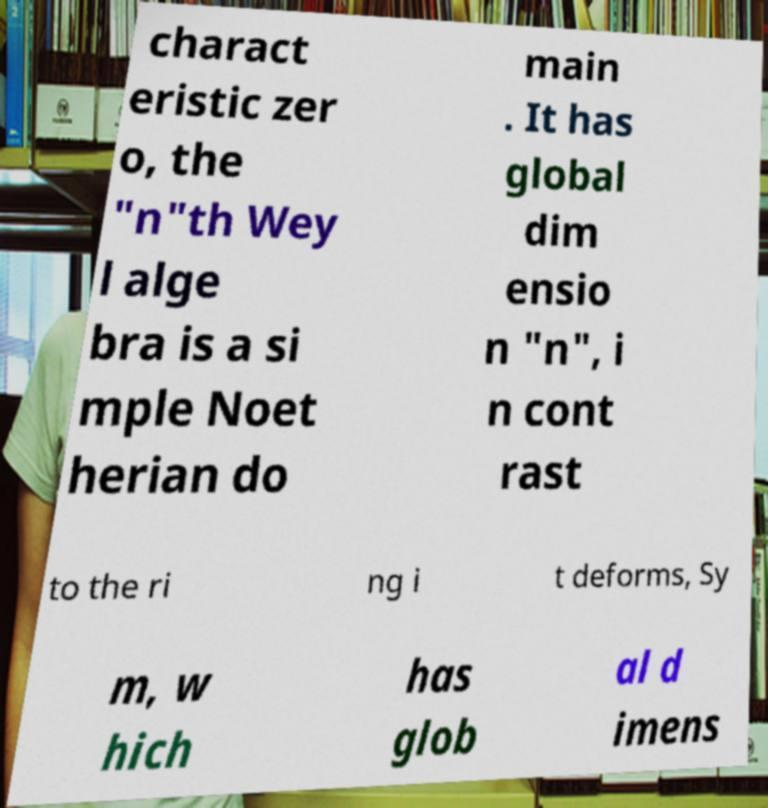Could you extract and type out the text from this image? charact eristic zer o, the "n"th Wey l alge bra is a si mple Noet herian do main . It has global dim ensio n "n", i n cont rast to the ri ng i t deforms, Sy m, w hich has glob al d imens 